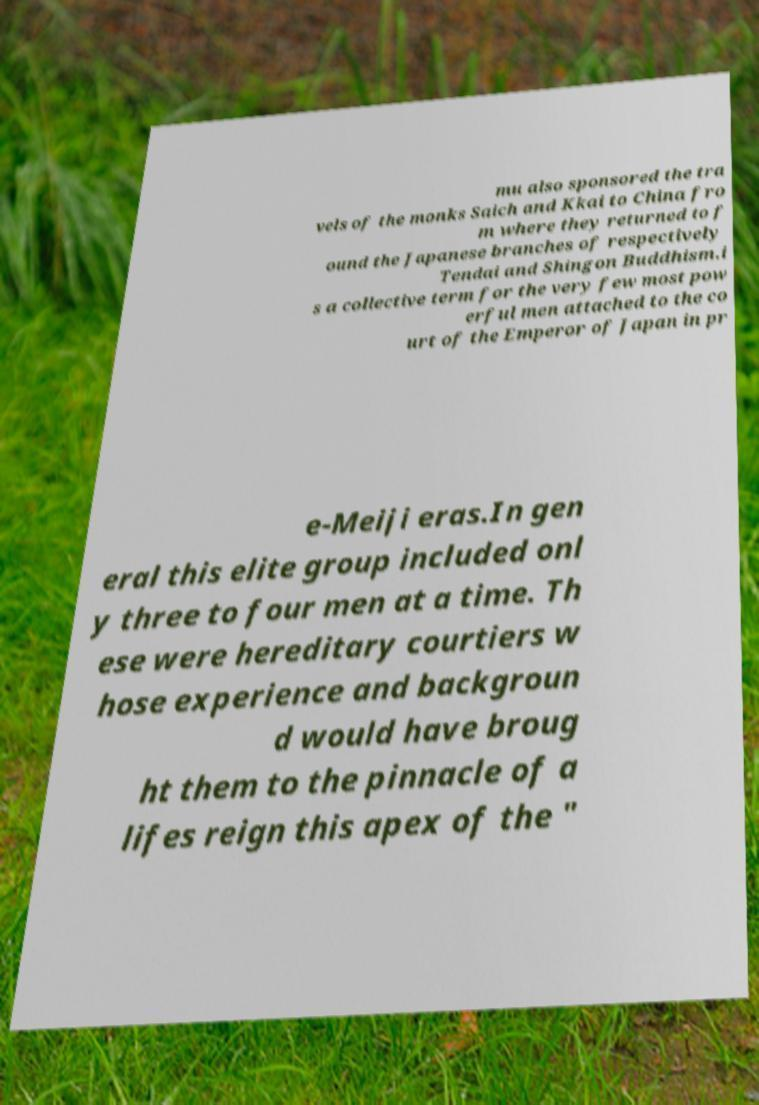Could you extract and type out the text from this image? mu also sponsored the tra vels of the monks Saich and Kkai to China fro m where they returned to f ound the Japanese branches of respectively Tendai and Shingon Buddhism.i s a collective term for the very few most pow erful men attached to the co urt of the Emperor of Japan in pr e-Meiji eras.In gen eral this elite group included onl y three to four men at a time. Th ese were hereditary courtiers w hose experience and backgroun d would have broug ht them to the pinnacle of a lifes reign this apex of the " 